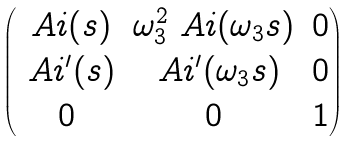<formula> <loc_0><loc_0><loc_500><loc_500>\begin{pmatrix} \ A i ( s ) & \omega _ { 3 } ^ { 2 } \ A i ( \omega _ { 3 } s ) & 0 \\ \ A i ^ { \prime } ( s ) & \ A i ^ { \prime } ( \omega _ { 3 } s ) & 0 \\ 0 & 0 & 1 \end{pmatrix}</formula> 